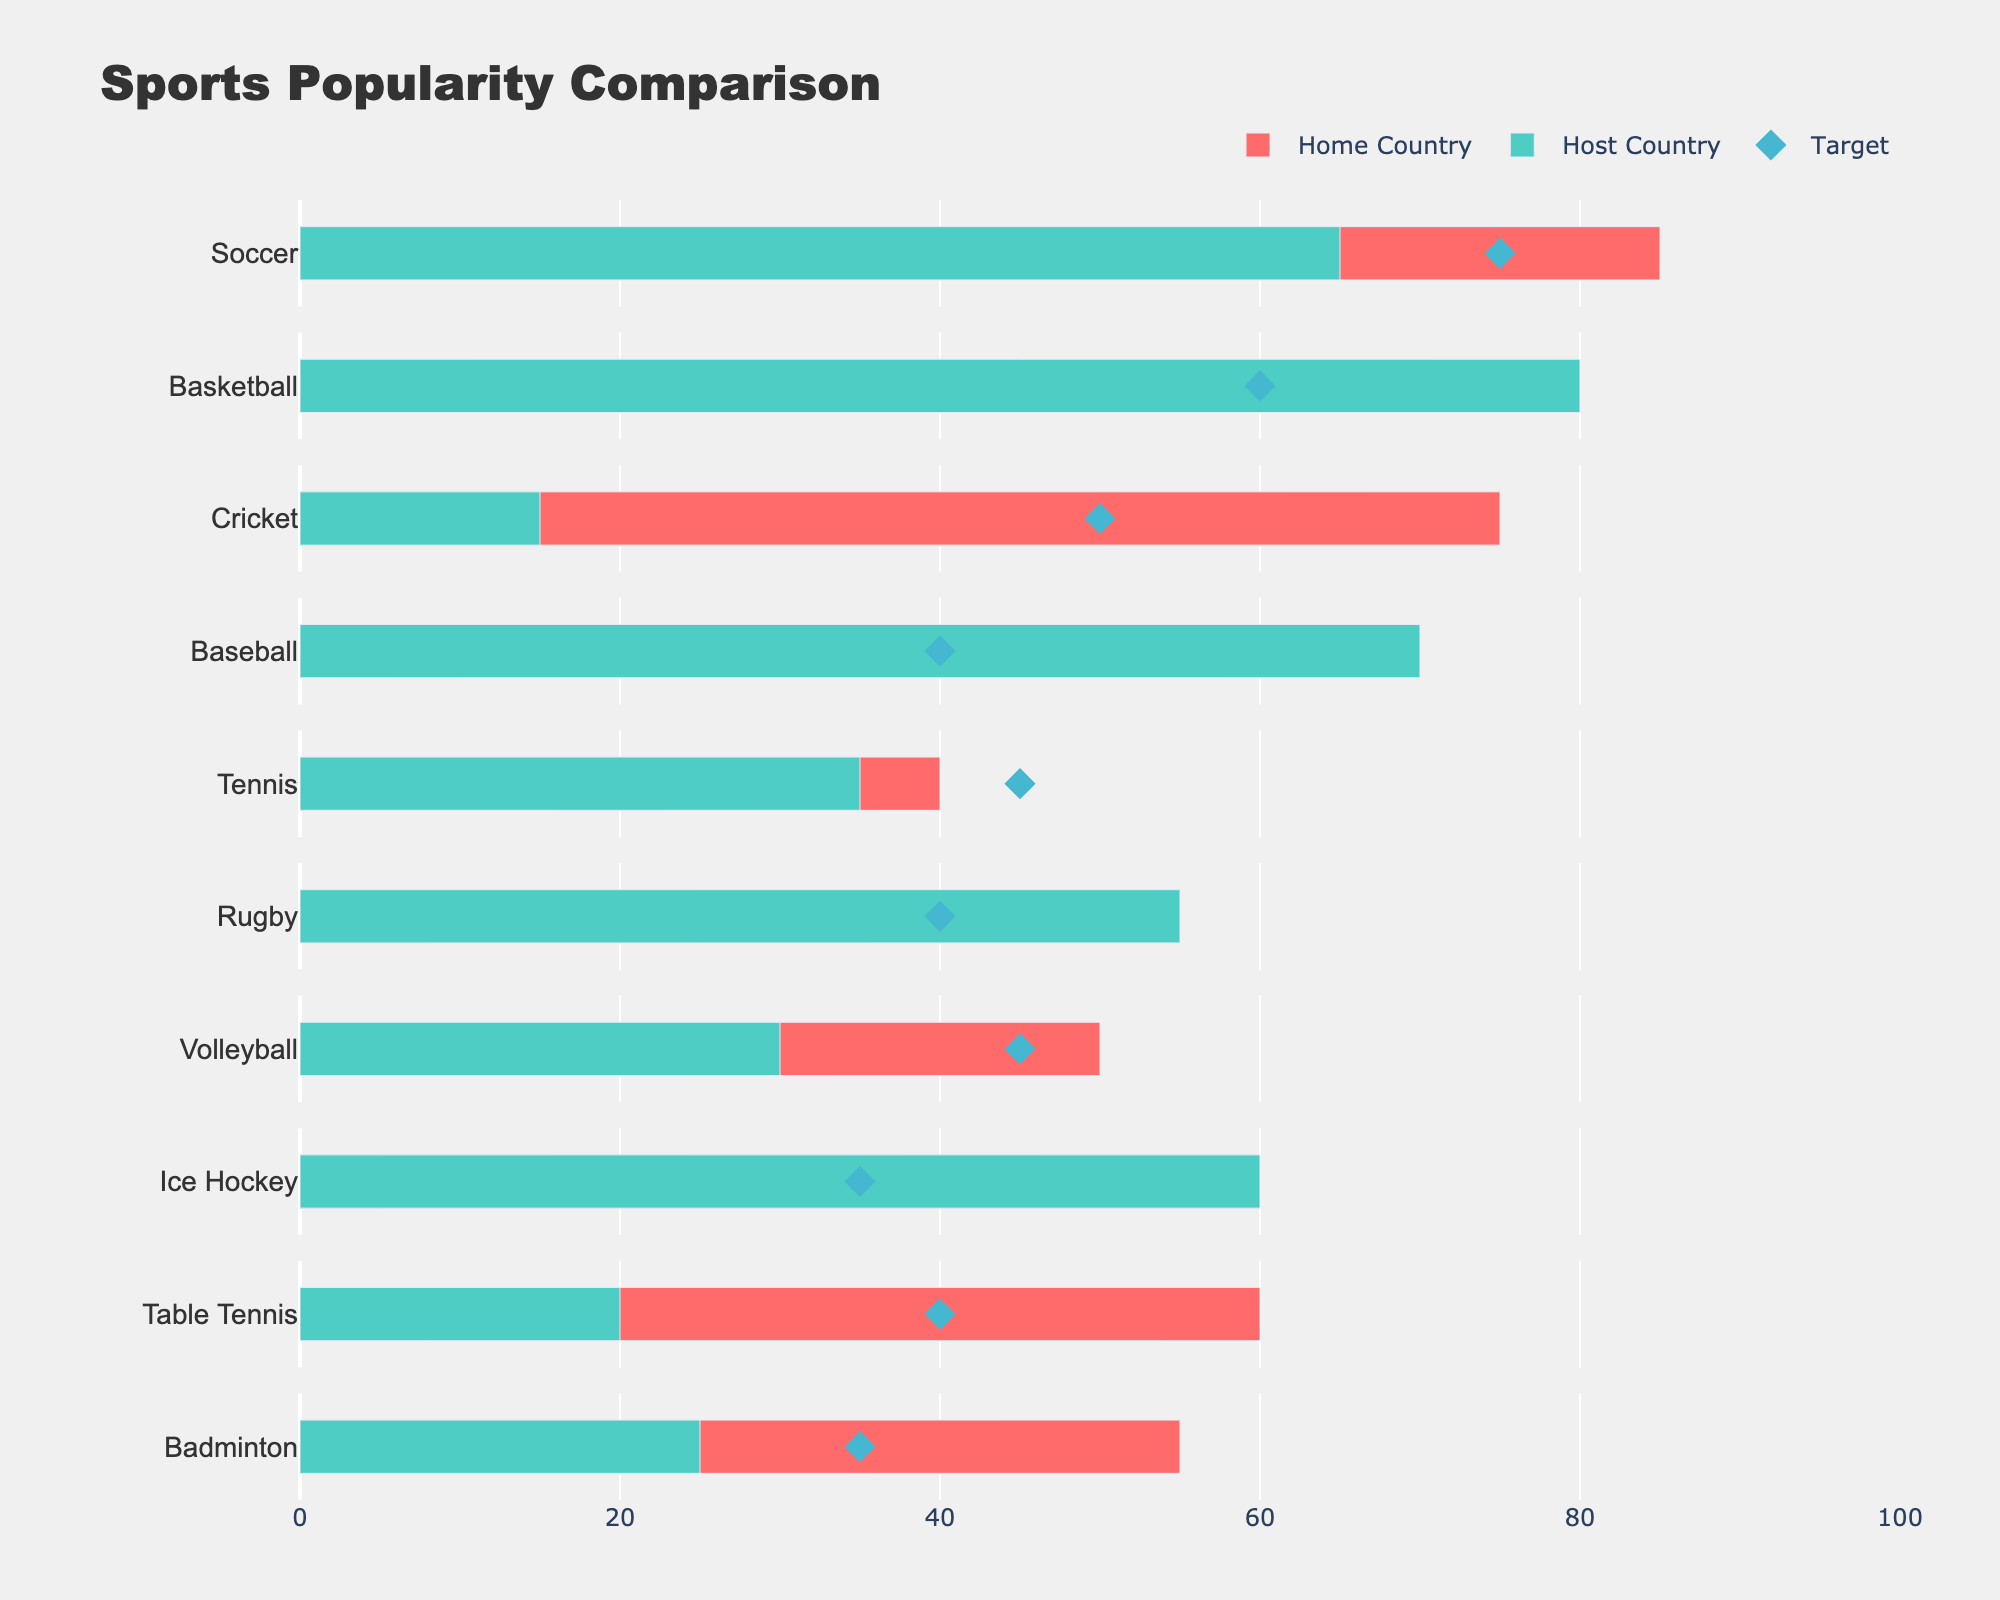How many sports were compared in the figure? The figure title mentions "Sports Popularity Comparison," and by counting the bars along the y-axis, we see there are multiple sports listed. Count the distinct y-axis labels for an exact number.
Answer: 10 Which sport has the highest popularity in the home country? By comparing the lengths of the bars for the "Home Country" category, we identify the sport with the longest bar in that category. Soccer has the longest bar.
Answer: Soccer What's the difference in Ice Hockey popularity between the host and home countries? Locate the bars for Ice Hockey and compare their lengths. Subtract the Home Country value (5) from the Host Country value (60).
Answer: 55 How many sports have a higher target popularity than their home country's popularity? Count the number of sports where the diamond marker (target) is to the right of the home country bar. Analyze each sport to determine this.
Answer: 7 For which sports is the home country popularity closer to the target than the host country's popularity? Identify the sports where the distance between the home country bar and the diamond marker (target) is less than the distance between the host country bar and the diamond marker. Examine each sport's bars and marker.
Answer: Soccer, Cricket, Tennis, Volleyball, Badminton Which sport shows the largest discrepancy in popularity between the home and host countries? Calculate the absolute differences for all sports between the home and host country bars. Identify the sport with the highest value. Ice Hockey has the largest discrepancy with 55 (60 - 5).
Answer: Ice Hockey What is the average target popularity across all sports? Sum all the target popularity values and divide by the number of sports. (75 + 60 + 50 + 40 + 45 + 40 + 45 + 35 + 40 + 35) / 10 = 465 / 10 = 46.5
Answer: 46.5 Which sport has a target popularity of 50? Referencing the diamond markers (target) and finding the one that aligns with 50 on the x-axis will lead to Cricket.
Answer: Cricket How many sports have less than 30% popularity in the home country? Count the number of home country bars that reach less than 30 on the x-axis. Examine each bar's length to determine this.
Answer: 3 Is there any sport where the home country's popularity, host country's popularity, and target popularity are all equal? Check each row's bars and target marker to see if any sport has all three values aligned on the same x-axis position. None of the sports have all three values the same.
Answer: No 